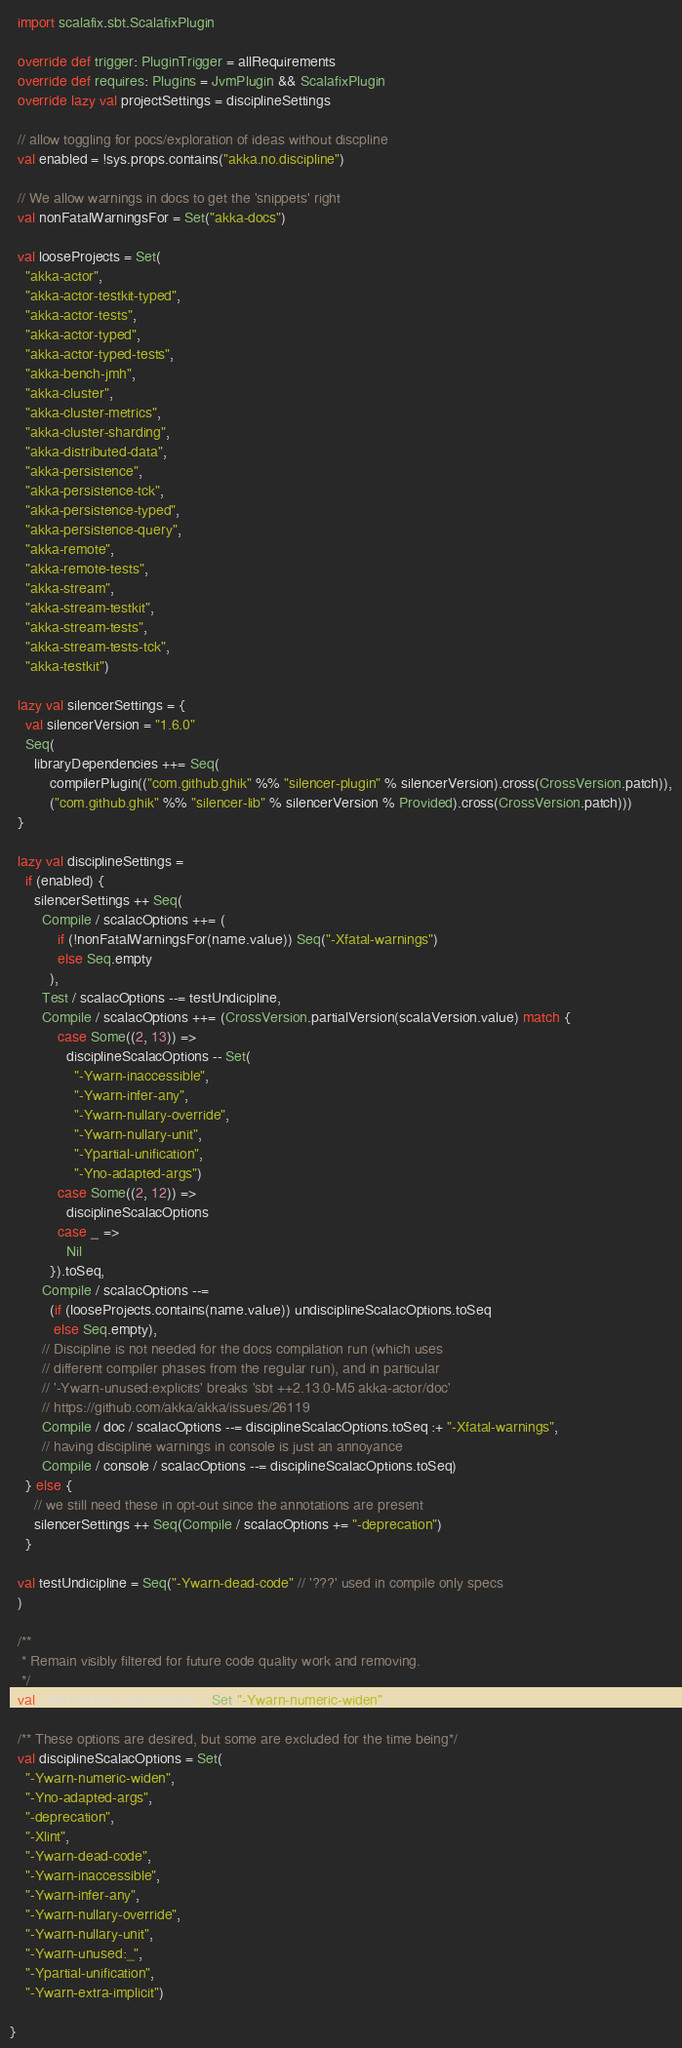<code> <loc_0><loc_0><loc_500><loc_500><_Scala_>  import scalafix.sbt.ScalafixPlugin

  override def trigger: PluginTrigger = allRequirements
  override def requires: Plugins = JvmPlugin && ScalafixPlugin
  override lazy val projectSettings = disciplineSettings

  // allow toggling for pocs/exploration of ideas without discpline
  val enabled = !sys.props.contains("akka.no.discipline")

  // We allow warnings in docs to get the 'snippets' right
  val nonFatalWarningsFor = Set("akka-docs")

  val looseProjects = Set(
    "akka-actor",
    "akka-actor-testkit-typed",
    "akka-actor-tests",
    "akka-actor-typed",
    "akka-actor-typed-tests",
    "akka-bench-jmh",
    "akka-cluster",
    "akka-cluster-metrics",
    "akka-cluster-sharding",
    "akka-distributed-data",
    "akka-persistence",
    "akka-persistence-tck",
    "akka-persistence-typed",
    "akka-persistence-query",
    "akka-remote",
    "akka-remote-tests",
    "akka-stream",
    "akka-stream-testkit",
    "akka-stream-tests",
    "akka-stream-tests-tck",
    "akka-testkit")

  lazy val silencerSettings = {
    val silencerVersion = "1.6.0"
    Seq(
      libraryDependencies ++= Seq(
          compilerPlugin(("com.github.ghik" %% "silencer-plugin" % silencerVersion).cross(CrossVersion.patch)),
          ("com.github.ghik" %% "silencer-lib" % silencerVersion % Provided).cross(CrossVersion.patch)))
  }

  lazy val disciplineSettings =
    if (enabled) {
      silencerSettings ++ Seq(
        Compile / scalacOptions ++= (
            if (!nonFatalWarningsFor(name.value)) Seq("-Xfatal-warnings")
            else Seq.empty
          ),
        Test / scalacOptions --= testUndicipline,
        Compile / scalacOptions ++= (CrossVersion.partialVersion(scalaVersion.value) match {
            case Some((2, 13)) =>
              disciplineScalacOptions -- Set(
                "-Ywarn-inaccessible",
                "-Ywarn-infer-any",
                "-Ywarn-nullary-override",
                "-Ywarn-nullary-unit",
                "-Ypartial-unification",
                "-Yno-adapted-args")
            case Some((2, 12)) =>
              disciplineScalacOptions
            case _ =>
              Nil
          }).toSeq,
        Compile / scalacOptions --=
          (if (looseProjects.contains(name.value)) undisciplineScalacOptions.toSeq
           else Seq.empty),
        // Discipline is not needed for the docs compilation run (which uses
        // different compiler phases from the regular run), and in particular
        // '-Ywarn-unused:explicits' breaks 'sbt ++2.13.0-M5 akka-actor/doc'
        // https://github.com/akka/akka/issues/26119
        Compile / doc / scalacOptions --= disciplineScalacOptions.toSeq :+ "-Xfatal-warnings",
        // having discipline warnings in console is just an annoyance
        Compile / console / scalacOptions --= disciplineScalacOptions.toSeq)
    } else {
      // we still need these in opt-out since the annotations are present
      silencerSettings ++ Seq(Compile / scalacOptions += "-deprecation")
    }

  val testUndicipline = Seq("-Ywarn-dead-code" // '???' used in compile only specs
  )

  /**
   * Remain visibly filtered for future code quality work and removing.
   */
  val undisciplineScalacOptions = Set("-Ywarn-numeric-widen")

  /** These options are desired, but some are excluded for the time being*/
  val disciplineScalacOptions = Set(
    "-Ywarn-numeric-widen",
    "-Yno-adapted-args",
    "-deprecation",
    "-Xlint",
    "-Ywarn-dead-code",
    "-Ywarn-inaccessible",
    "-Ywarn-infer-any",
    "-Ywarn-nullary-override",
    "-Ywarn-nullary-unit",
    "-Ywarn-unused:_",
    "-Ypartial-unification",
    "-Ywarn-extra-implicit")

}
</code> 